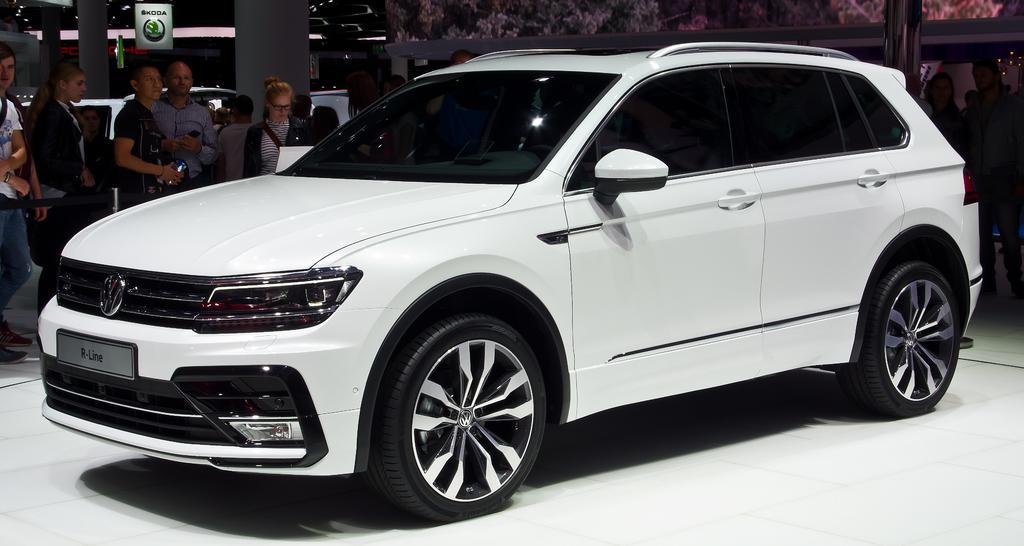Can you describe this image briefly? Here in this picture we can see a white colored car present on the floor and beside that we can see number of people standing and watching it and we can also see hoardings present and we can see lights present on the roof. 